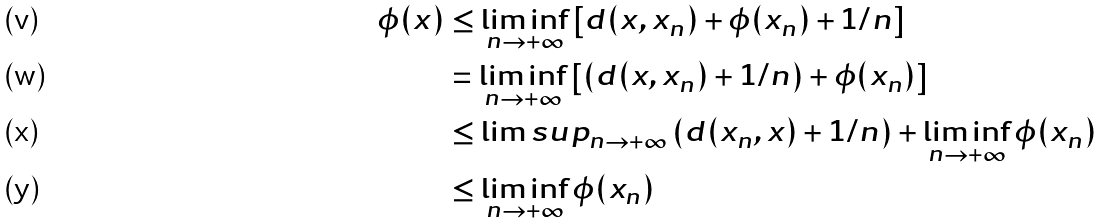Convert formula to latex. <formula><loc_0><loc_0><loc_500><loc_500>\phi ( x ) & \leq \liminf _ { n \to + \infty } \left [ d ( x , x _ { n } ) + \phi ( x _ { n } ) + 1 / n \right ] \\ & = \liminf _ { n \to + \infty } \left [ \left ( d ( x , x _ { n } ) + 1 / n \right ) + \phi ( x _ { n } ) \right ] \\ & \leq \lim s u p _ { n \to + \infty } \left ( d ( x _ { n } , x ) + 1 / n \right ) + \liminf _ { n \to + \infty } \phi ( x _ { n } ) \\ & \leq \liminf _ { n \to + \infty } \phi ( x _ { n } )</formula> 